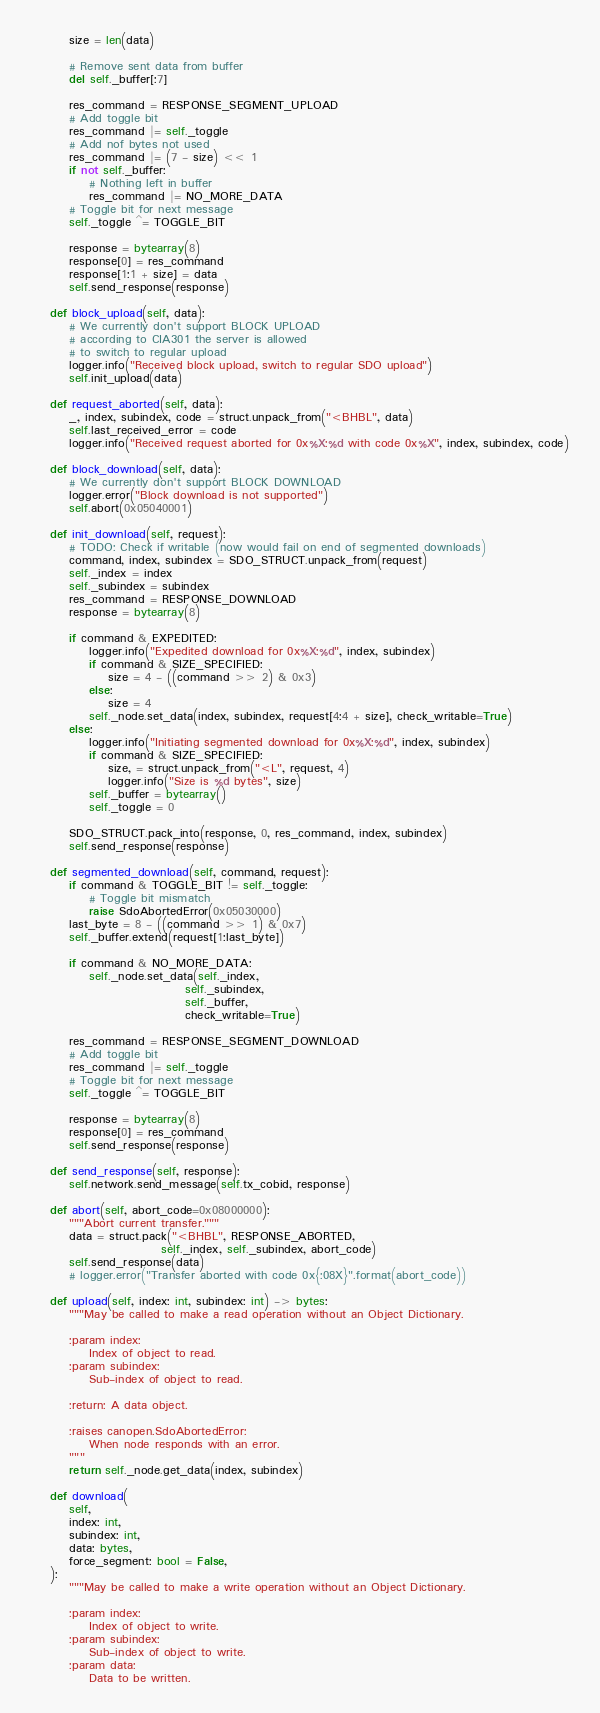Convert code to text. <code><loc_0><loc_0><loc_500><loc_500><_Python_>        size = len(data)

        # Remove sent data from buffer
        del self._buffer[:7]

        res_command = RESPONSE_SEGMENT_UPLOAD
        # Add toggle bit
        res_command |= self._toggle
        # Add nof bytes not used
        res_command |= (7 - size) << 1
        if not self._buffer:
            # Nothing left in buffer
            res_command |= NO_MORE_DATA
        # Toggle bit for next message
        self._toggle ^= TOGGLE_BIT

        response = bytearray(8)
        response[0] = res_command
        response[1:1 + size] = data
        self.send_response(response)

    def block_upload(self, data):
        # We currently don't support BLOCK UPLOAD
        # according to CIA301 the server is allowed
        # to switch to regular upload
        logger.info("Received block upload, switch to regular SDO upload")
        self.init_upload(data)

    def request_aborted(self, data):
        _, index, subindex, code = struct.unpack_from("<BHBL", data)
        self.last_received_error = code
        logger.info("Received request aborted for 0x%X:%d with code 0x%X", index, subindex, code)

    def block_download(self, data):
        # We currently don't support BLOCK DOWNLOAD
        logger.error("Block download is not supported")
        self.abort(0x05040001)

    def init_download(self, request):
        # TODO: Check if writable (now would fail on end of segmented downloads)
        command, index, subindex = SDO_STRUCT.unpack_from(request)
        self._index = index
        self._subindex = subindex
        res_command = RESPONSE_DOWNLOAD
        response = bytearray(8)

        if command & EXPEDITED:
            logger.info("Expedited download for 0x%X:%d", index, subindex)
            if command & SIZE_SPECIFIED:
                size = 4 - ((command >> 2) & 0x3)
            else:
                size = 4
            self._node.set_data(index, subindex, request[4:4 + size], check_writable=True)
        else:
            logger.info("Initiating segmented download for 0x%X:%d", index, subindex)
            if command & SIZE_SPECIFIED:
                size, = struct.unpack_from("<L", request, 4)
                logger.info("Size is %d bytes", size)
            self._buffer = bytearray()
            self._toggle = 0

        SDO_STRUCT.pack_into(response, 0, res_command, index, subindex)
        self.send_response(response)

    def segmented_download(self, command, request):
        if command & TOGGLE_BIT != self._toggle:
            # Toggle bit mismatch
            raise SdoAbortedError(0x05030000)
        last_byte = 8 - ((command >> 1) & 0x7)
        self._buffer.extend(request[1:last_byte])

        if command & NO_MORE_DATA:
            self._node.set_data(self._index,
                                self._subindex,
                                self._buffer,
                                check_writable=True)

        res_command = RESPONSE_SEGMENT_DOWNLOAD
        # Add toggle bit
        res_command |= self._toggle
        # Toggle bit for next message
        self._toggle ^= TOGGLE_BIT

        response = bytearray(8)
        response[0] = res_command
        self.send_response(response)

    def send_response(self, response):
        self.network.send_message(self.tx_cobid, response)

    def abort(self, abort_code=0x08000000):
        """Abort current transfer."""
        data = struct.pack("<BHBL", RESPONSE_ABORTED,
                           self._index, self._subindex, abort_code)
        self.send_response(data)
        # logger.error("Transfer aborted with code 0x{:08X}".format(abort_code))

    def upload(self, index: int, subindex: int) -> bytes:
        """May be called to make a read operation without an Object Dictionary.

        :param index:
            Index of object to read.
        :param subindex:
            Sub-index of object to read.

        :return: A data object.

        :raises canopen.SdoAbortedError:
            When node responds with an error.
        """
        return self._node.get_data(index, subindex)

    def download(
        self,
        index: int,
        subindex: int,
        data: bytes,
        force_segment: bool = False,
    ):
        """May be called to make a write operation without an Object Dictionary. 

        :param index:
            Index of object to write.
        :param subindex:
            Sub-index of object to write.
        :param data:
            Data to be written.
</code> 